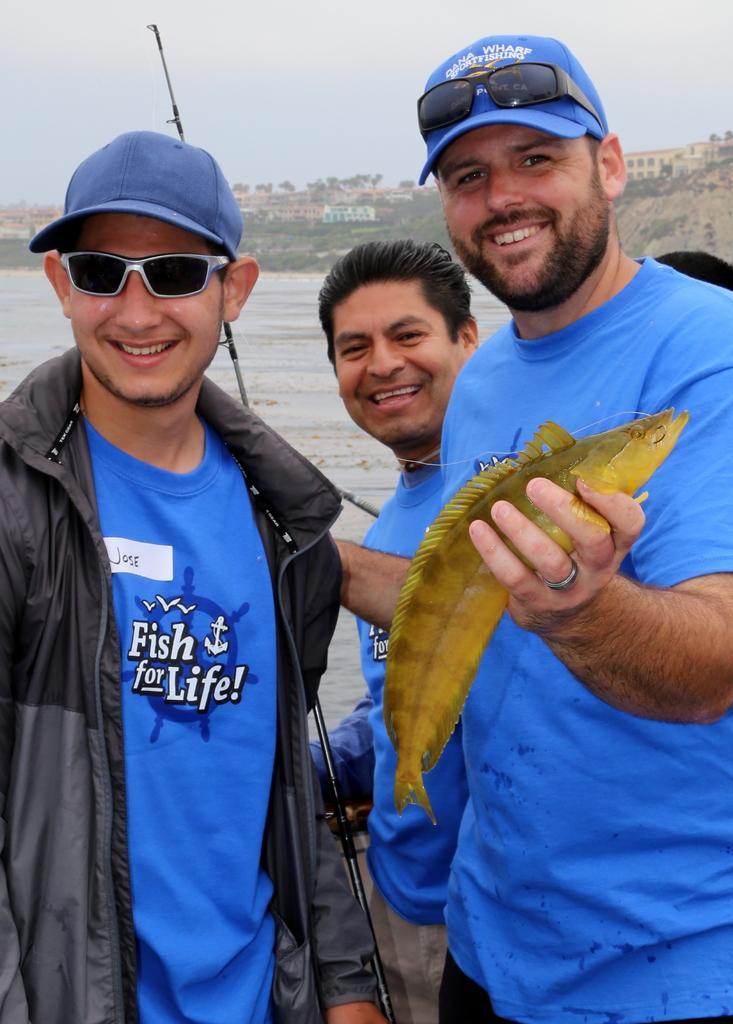Please provide a concise description of this image. There are three men standing and smiling. This man is holding a fish and the fishing stick in his hands. This looks like a water. In the background, I can see the buildings and trees on the hill. 